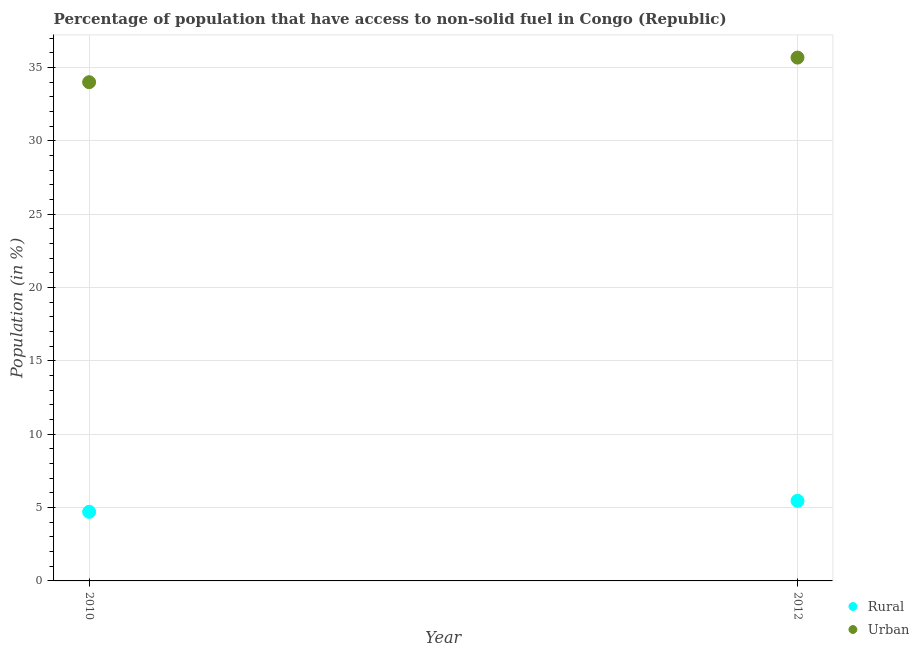How many different coloured dotlines are there?
Provide a succinct answer. 2. What is the rural population in 2012?
Give a very brief answer. 5.46. Across all years, what is the maximum urban population?
Your answer should be compact. 35.69. Across all years, what is the minimum urban population?
Your response must be concise. 34.01. In which year was the urban population minimum?
Ensure brevity in your answer.  2010. What is the total urban population in the graph?
Your answer should be very brief. 69.69. What is the difference between the rural population in 2010 and that in 2012?
Provide a succinct answer. -0.75. What is the difference between the rural population in 2010 and the urban population in 2012?
Offer a very short reply. -30.97. What is the average urban population per year?
Provide a succinct answer. 34.85. In the year 2012, what is the difference between the urban population and rural population?
Your answer should be compact. 30.23. In how many years, is the urban population greater than 33 %?
Your response must be concise. 2. What is the ratio of the urban population in 2010 to that in 2012?
Ensure brevity in your answer.  0.95. In how many years, is the urban population greater than the average urban population taken over all years?
Your response must be concise. 1. Does the urban population monotonically increase over the years?
Your response must be concise. Yes. Is the urban population strictly less than the rural population over the years?
Make the answer very short. No. How many years are there in the graph?
Your response must be concise. 2. Are the values on the major ticks of Y-axis written in scientific E-notation?
Ensure brevity in your answer.  No. Does the graph contain any zero values?
Your answer should be very brief. No. What is the title of the graph?
Keep it short and to the point. Percentage of population that have access to non-solid fuel in Congo (Republic). What is the Population (in %) of Rural in 2010?
Your answer should be compact. 4.71. What is the Population (in %) in Urban in 2010?
Give a very brief answer. 34.01. What is the Population (in %) of Rural in 2012?
Offer a very short reply. 5.46. What is the Population (in %) in Urban in 2012?
Offer a terse response. 35.69. Across all years, what is the maximum Population (in %) of Rural?
Make the answer very short. 5.46. Across all years, what is the maximum Population (in %) in Urban?
Give a very brief answer. 35.69. Across all years, what is the minimum Population (in %) of Rural?
Offer a very short reply. 4.71. Across all years, what is the minimum Population (in %) in Urban?
Your response must be concise. 34.01. What is the total Population (in %) of Rural in the graph?
Give a very brief answer. 10.17. What is the total Population (in %) in Urban in the graph?
Your response must be concise. 69.69. What is the difference between the Population (in %) in Rural in 2010 and that in 2012?
Your response must be concise. -0.75. What is the difference between the Population (in %) in Urban in 2010 and that in 2012?
Provide a succinct answer. -1.68. What is the difference between the Population (in %) in Rural in 2010 and the Population (in %) in Urban in 2012?
Offer a terse response. -30.97. What is the average Population (in %) of Rural per year?
Your response must be concise. 5.09. What is the average Population (in %) of Urban per year?
Keep it short and to the point. 34.85. In the year 2010, what is the difference between the Population (in %) of Rural and Population (in %) of Urban?
Ensure brevity in your answer.  -29.3. In the year 2012, what is the difference between the Population (in %) in Rural and Population (in %) in Urban?
Offer a very short reply. -30.23. What is the ratio of the Population (in %) in Rural in 2010 to that in 2012?
Your answer should be very brief. 0.86. What is the ratio of the Population (in %) of Urban in 2010 to that in 2012?
Provide a succinct answer. 0.95. What is the difference between the highest and the second highest Population (in %) in Rural?
Your answer should be very brief. 0.75. What is the difference between the highest and the second highest Population (in %) of Urban?
Offer a terse response. 1.68. What is the difference between the highest and the lowest Population (in %) in Rural?
Provide a short and direct response. 0.75. What is the difference between the highest and the lowest Population (in %) in Urban?
Make the answer very short. 1.68. 